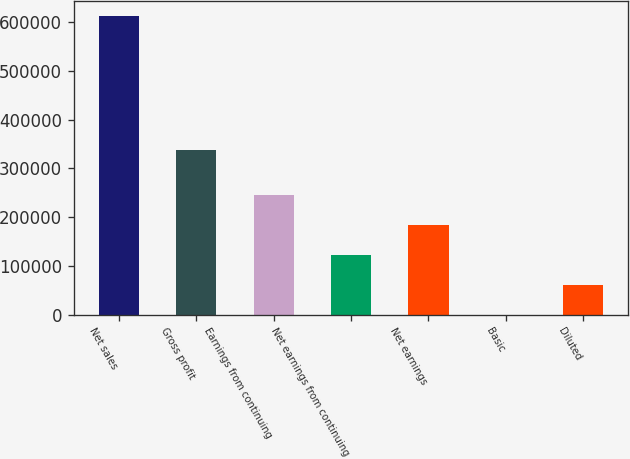Convert chart to OTSL. <chart><loc_0><loc_0><loc_500><loc_500><bar_chart><fcel>Net sales<fcel>Gross profit<fcel>Earnings from continuing<fcel>Net earnings from continuing<fcel>Net earnings<fcel>Basic<fcel>Diluted<nl><fcel>612493<fcel>337452<fcel>244997<fcel>122499<fcel>183748<fcel>0.46<fcel>61249.7<nl></chart> 